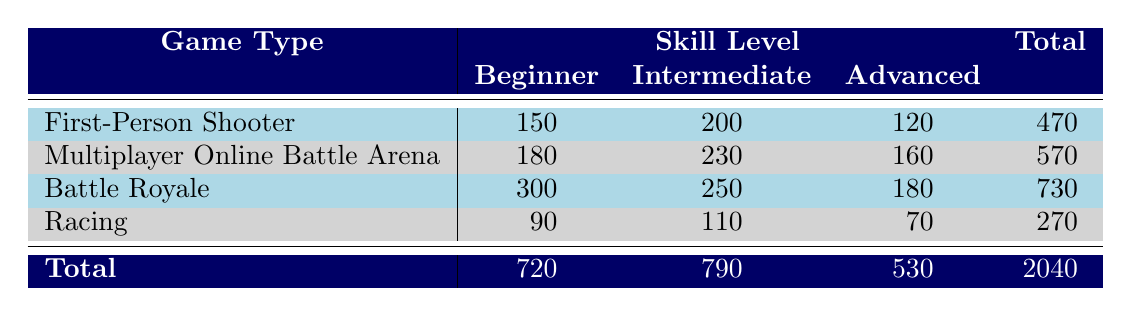What is the total number of participants in Battle Royale? The table shows that for Battle Royale, there are 300 participants at the Beginner level, 250 at Intermediate, and 180 at Advanced. Adding these together gives 300 + 250 + 180 = 730.
Answer: 730 What is the number of Intermediate participants in Multiplayer Online Battle Arena? The table indicates that there are 230 participants at the Intermediate skill level for Multiplayer Online Battle Arena.
Answer: 230 Is there a greater number of Beginner participants in Racing than in First-Person Shooter? Racing has 90 Beginner participants, while First-Person Shooter has 150. Since 90 is less than 150, the statement is false.
Answer: No What is the average number of participants across all skill levels for the game type with the highest total? The game type with the highest total is Battle Royale with 730 participants. It has 300 (Beginner) + 250 (Intermediate) + 180 (Advanced) = 730. The average is 730/3 = 243.33.
Answer: 243.33 Which game type has the most Advanced participants? From the table, Battle Royale has 180 Advanced participants, which is more than any other game type: First-Person Shooter has 120 and Multiplayer Online Battle Arena has 160. Therefore, Battle Royale has the most.
Answer: Battle Royale How many total participants are there across all game types? To find the total, we need to sum the totals for each game type. First-Person Shooter has 470, Multiplayer Online Battle Arena has 570, Battle Royale has 730, and Racing has 270. The total participants are 470 + 570 + 730 + 270 = 2040.
Answer: 2040 Which skill level has the fewest participants overall? The skill level totals are: Beginner = 720, Intermediate = 790, Advanced = 530. The fewest participants are in the Advanced skill level, which has a total of 530.
Answer: Advanced What is the difference in participants between Intermediate and Advanced levels? The total for Intermediate skill level is 790 and for Advanced, it is 530. The difference is calculated as 790 - 530 = 260.
Answer: 260 